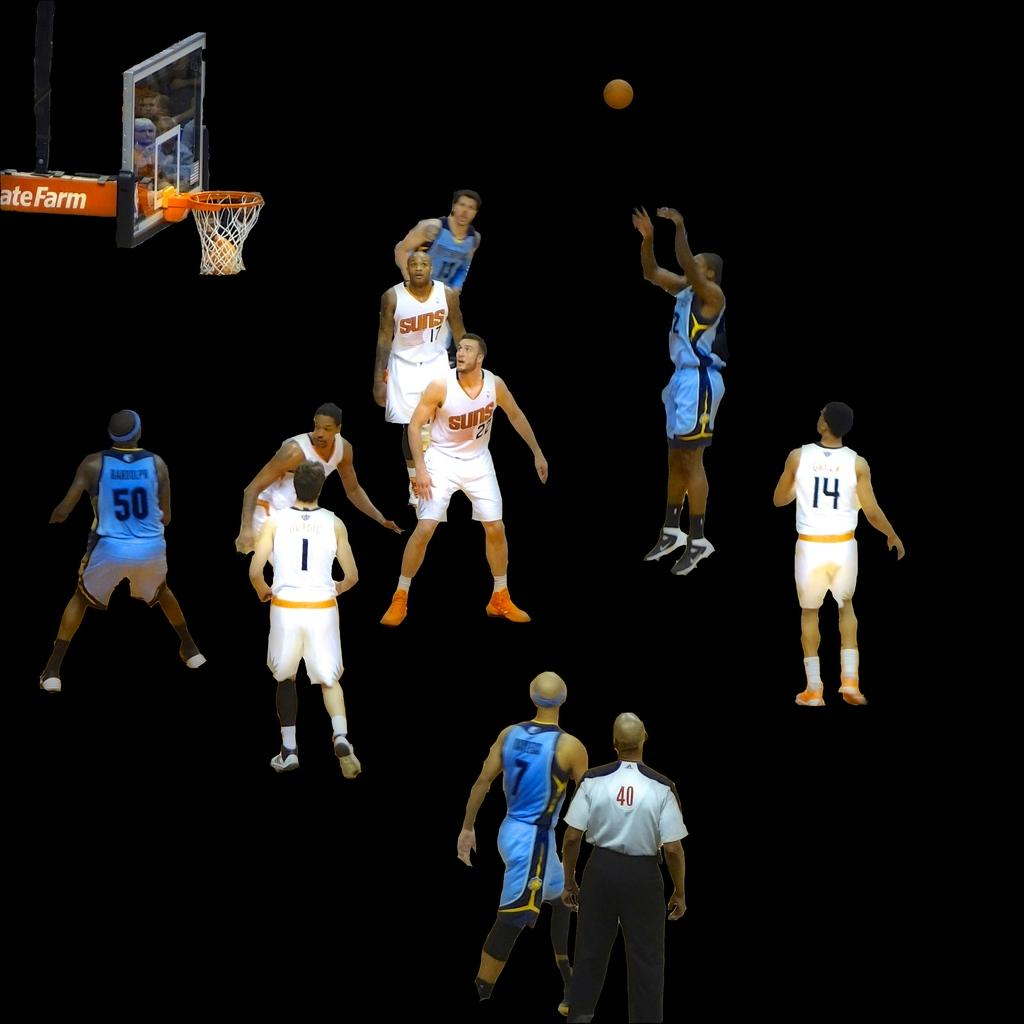<image>
Give a short and clear explanation of the subsequent image. A basketball gave is underway and one teams' jerseys say Suns and the court is a dark background. 